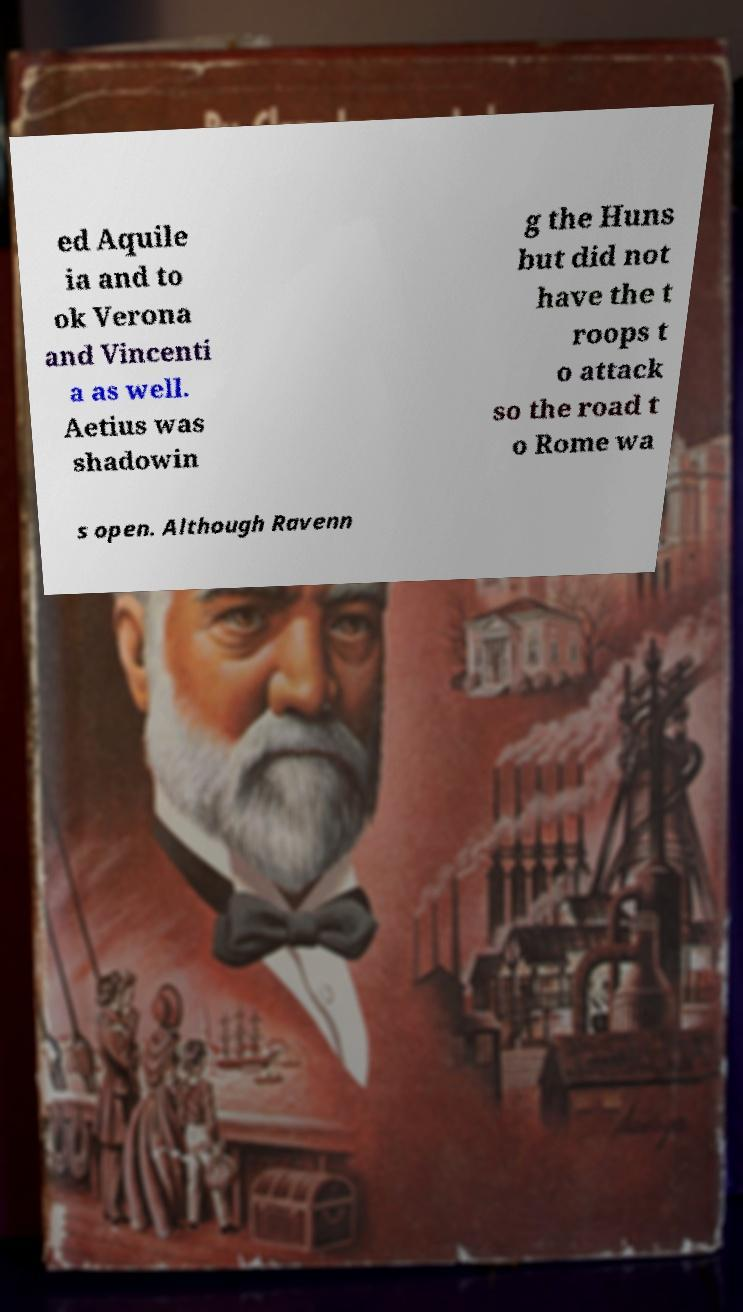There's text embedded in this image that I need extracted. Can you transcribe it verbatim? ed Aquile ia and to ok Verona and Vincenti a as well. Aetius was shadowin g the Huns but did not have the t roops t o attack so the road t o Rome wa s open. Although Ravenn 